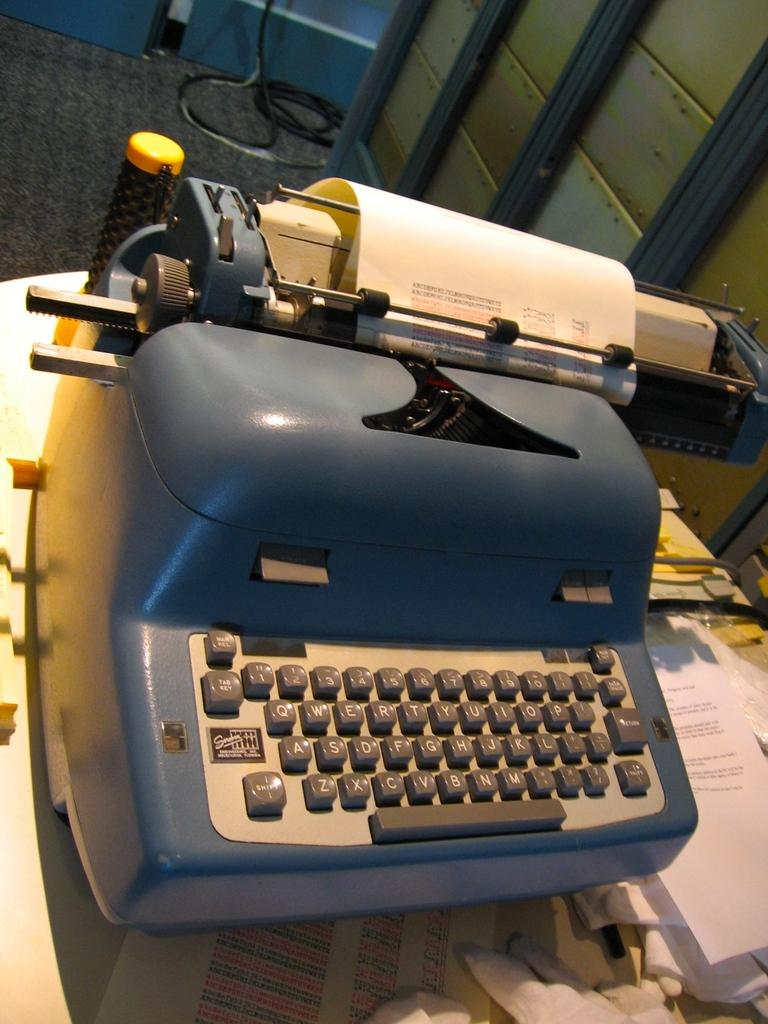<image>
Summarize the visual content of the image. An old style typewriter which has a tab key visible. 